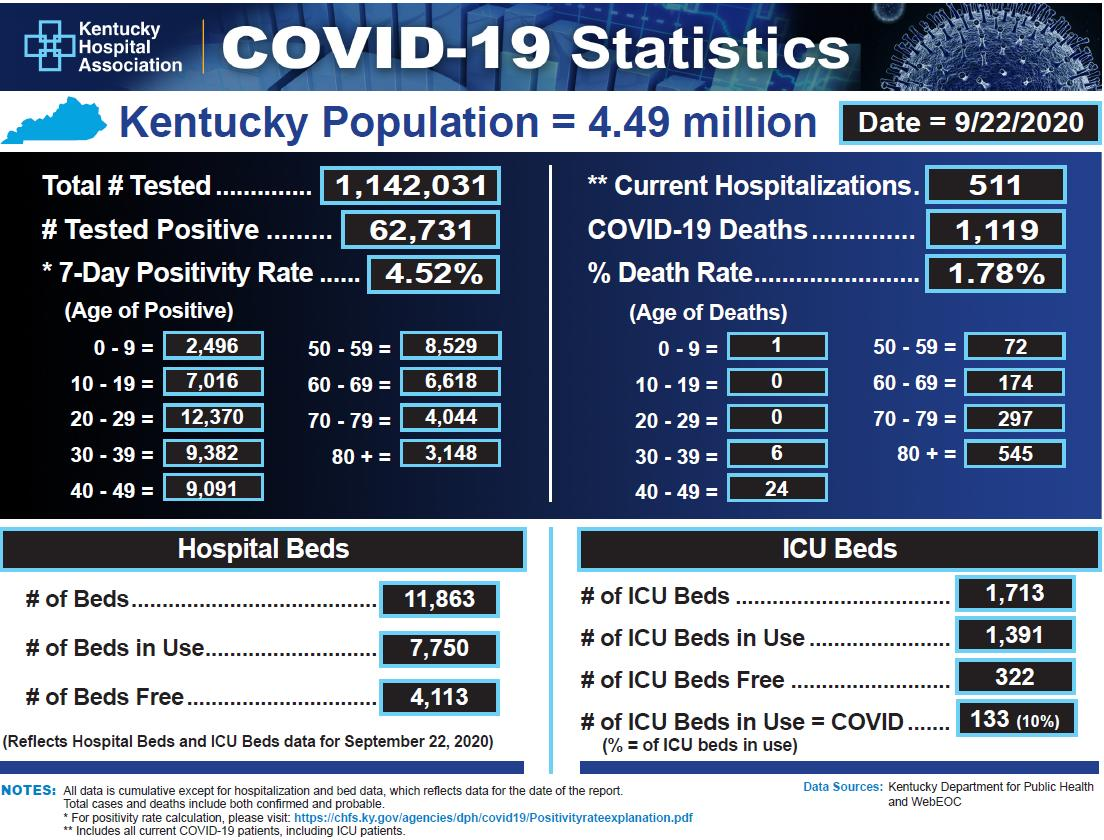Point out several critical features in this image. According to data reported as of September 22, 2020, the age group that has reported the highest number of COVID-19 deaths in Kentucky is individuals aged 80 or older. As of September 22nd, 2020, there were a total of 62,731 confirmed cases of COVID-19 in the state of Kentucky. The age group that has reported the least number of Covid positive cases in Kentucky as of 9/22/2020 is individuals under the age of 10. As of September 22, 2020, the death rate due to COVID-19 in Kentucky was 1.78%. As of September 22, 2020, it was reported that approximately 10% of ICU beds in Kentucky hospitals were being used to treat COVID-19 patients. 